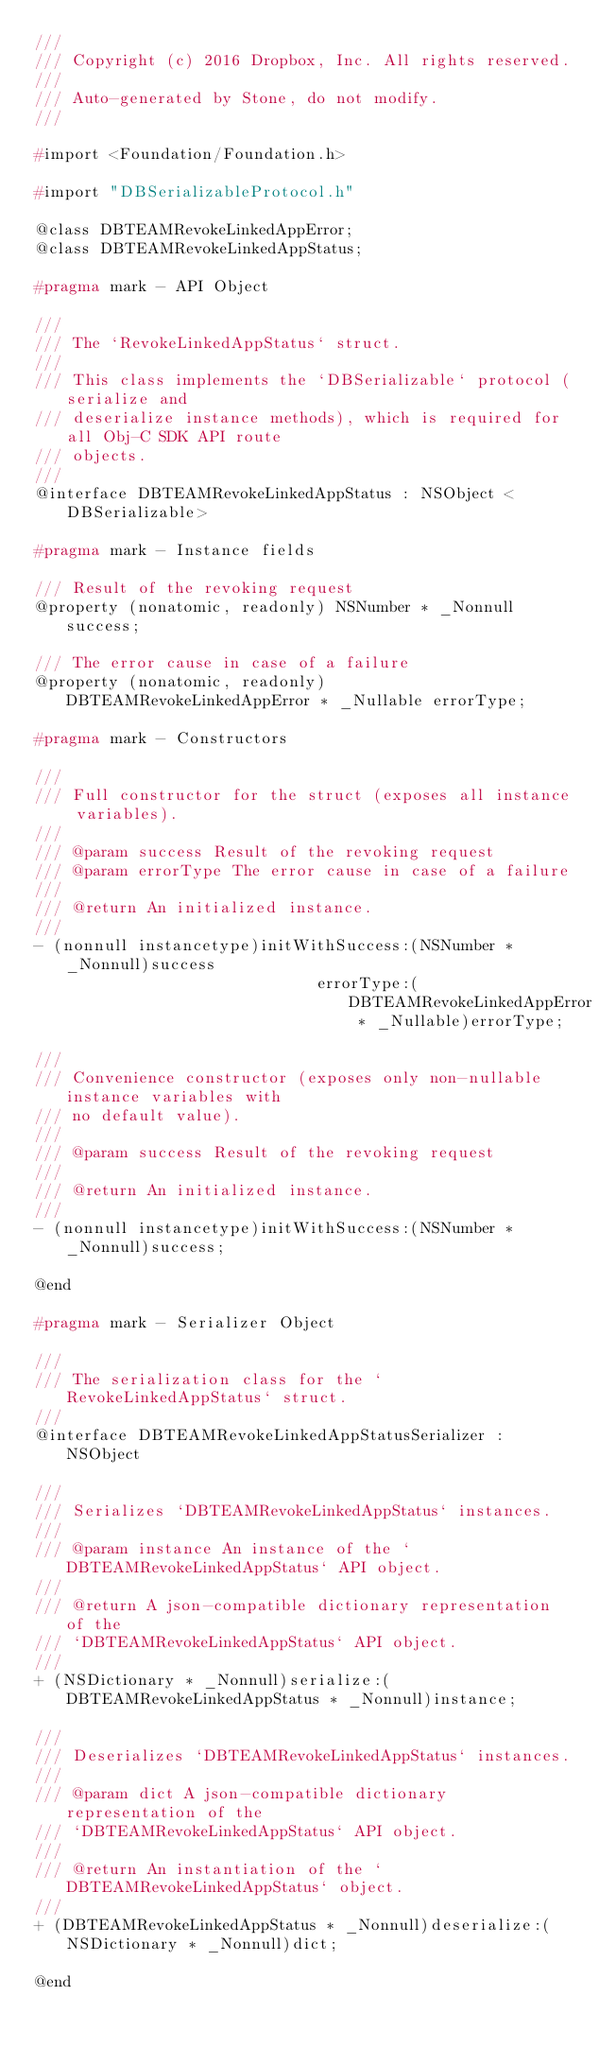Convert code to text. <code><loc_0><loc_0><loc_500><loc_500><_C_>///
/// Copyright (c) 2016 Dropbox, Inc. All rights reserved.
///
/// Auto-generated by Stone, do not modify.
///

#import <Foundation/Foundation.h>

#import "DBSerializableProtocol.h"

@class DBTEAMRevokeLinkedAppError;
@class DBTEAMRevokeLinkedAppStatus;

#pragma mark - API Object

///
/// The `RevokeLinkedAppStatus` struct.
///
/// This class implements the `DBSerializable` protocol (serialize and
/// deserialize instance methods), which is required for all Obj-C SDK API route
/// objects.
///
@interface DBTEAMRevokeLinkedAppStatus : NSObject <DBSerializable>

#pragma mark - Instance fields

/// Result of the revoking request
@property (nonatomic, readonly) NSNumber * _Nonnull success;

/// The error cause in case of a failure
@property (nonatomic, readonly) DBTEAMRevokeLinkedAppError * _Nullable errorType;

#pragma mark - Constructors

///
/// Full constructor for the struct (exposes all instance variables).
///
/// @param success Result of the revoking request
/// @param errorType The error cause in case of a failure
///
/// @return An initialized instance.
///
- (nonnull instancetype)initWithSuccess:(NSNumber * _Nonnull)success
                              errorType:(DBTEAMRevokeLinkedAppError * _Nullable)errorType;

///
/// Convenience constructor (exposes only non-nullable instance variables with
/// no default value).
///
/// @param success Result of the revoking request
///
/// @return An initialized instance.
///
- (nonnull instancetype)initWithSuccess:(NSNumber * _Nonnull)success;

@end

#pragma mark - Serializer Object

///
/// The serialization class for the `RevokeLinkedAppStatus` struct.
///
@interface DBTEAMRevokeLinkedAppStatusSerializer : NSObject

///
/// Serializes `DBTEAMRevokeLinkedAppStatus` instances.
///
/// @param instance An instance of the `DBTEAMRevokeLinkedAppStatus` API object.
///
/// @return A json-compatible dictionary representation of the
/// `DBTEAMRevokeLinkedAppStatus` API object.
///
+ (NSDictionary * _Nonnull)serialize:(DBTEAMRevokeLinkedAppStatus * _Nonnull)instance;

///
/// Deserializes `DBTEAMRevokeLinkedAppStatus` instances.
///
/// @param dict A json-compatible dictionary representation of the
/// `DBTEAMRevokeLinkedAppStatus` API object.
///
/// @return An instantiation of the `DBTEAMRevokeLinkedAppStatus` object.
///
+ (DBTEAMRevokeLinkedAppStatus * _Nonnull)deserialize:(NSDictionary * _Nonnull)dict;

@end
</code> 